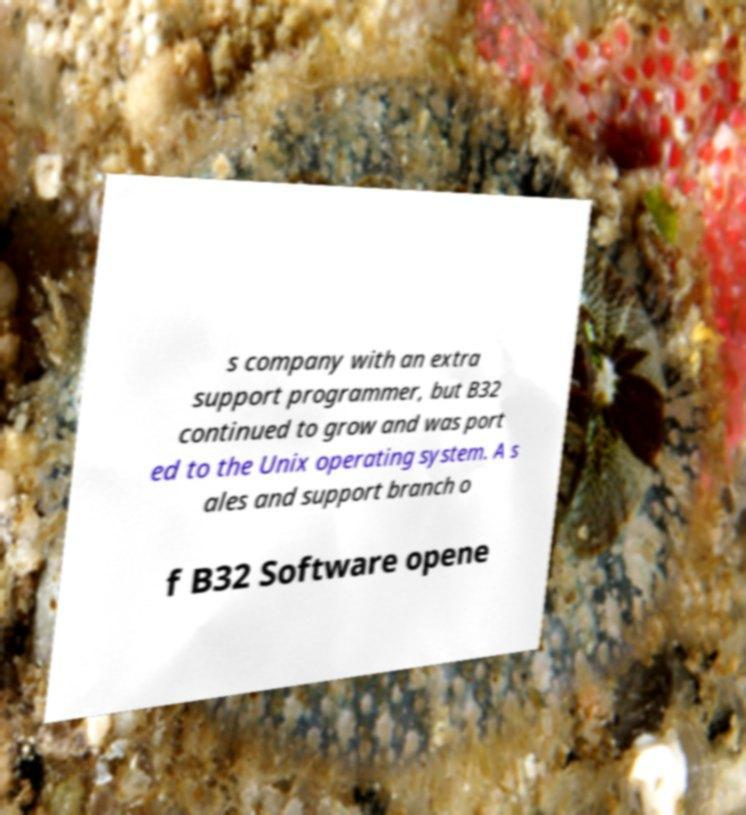Can you read and provide the text displayed in the image?This photo seems to have some interesting text. Can you extract and type it out for me? s company with an extra support programmer, but B32 continued to grow and was port ed to the Unix operating system. A s ales and support branch o f B32 Software opene 